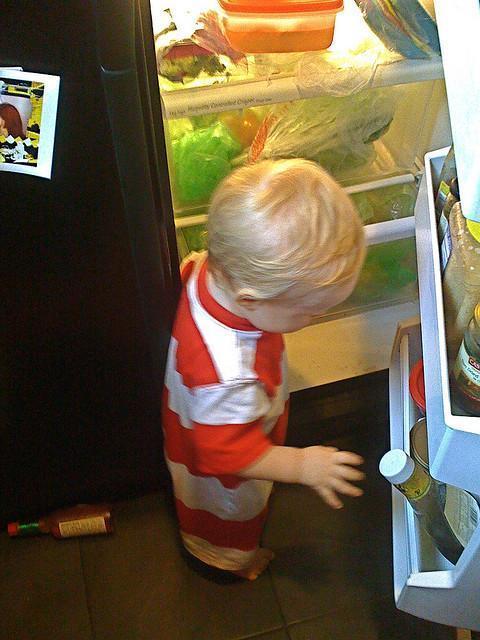How many bottles can be seen?
Give a very brief answer. 2. How many broccolis can be seen?
Give a very brief answer. 2. 